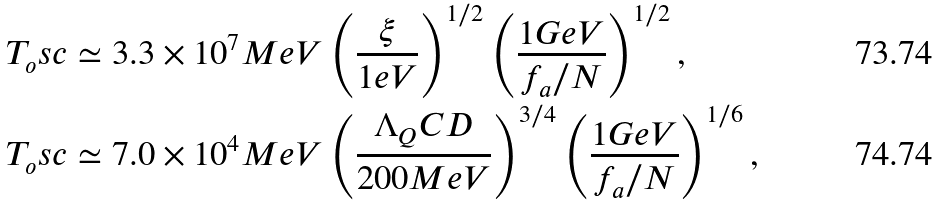Convert formula to latex. <formula><loc_0><loc_0><loc_500><loc_500>T _ { o } s c & \simeq 3 . 3 \times 1 0 ^ { 7 } M e V \left ( \frac { \xi } { 1 e V } \right ) ^ { 1 / 2 } \left ( \frac { 1 G e V } { f _ { a } / N } \right ) ^ { 1 / 2 } , \\ T _ { o } s c & \simeq 7 . 0 \times 1 0 ^ { 4 } M e V \left ( \frac { \Lambda _ { Q } C D } { 2 0 0 M e V } \right ) ^ { 3 / 4 } \left ( \frac { 1 G e V } { f _ { a } / N } \right ) ^ { 1 / 6 } ,</formula> 